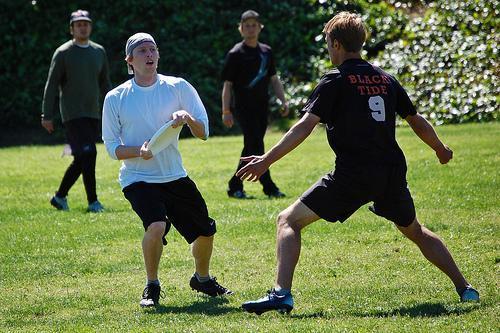How many men are here?
Give a very brief answer. 4. 